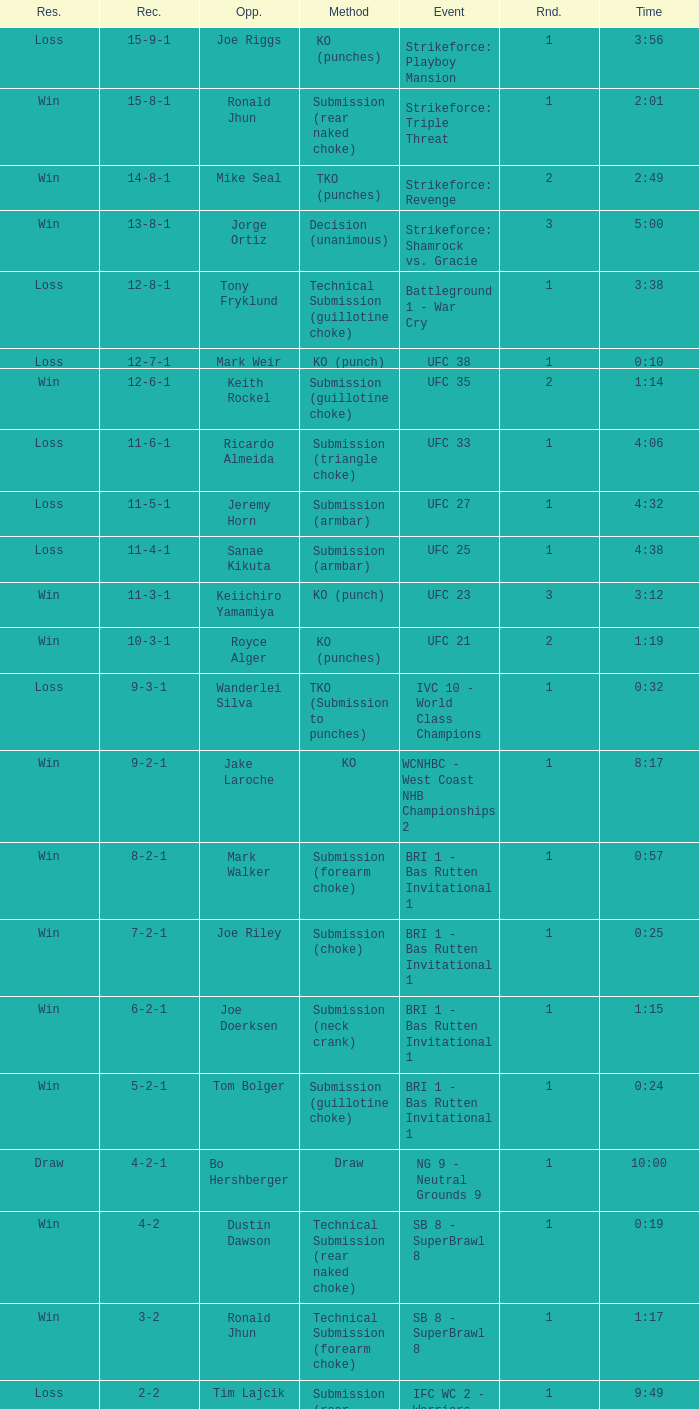Who was the opponent when the fight had a time of 2:01? Ronald Jhun. 